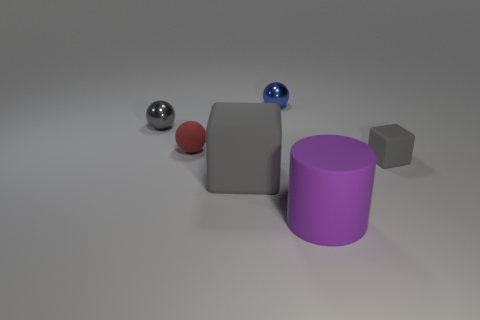Subtract all small rubber balls. How many balls are left? 2 Subtract 1 balls. How many balls are left? 2 Add 3 small red rubber things. How many objects exist? 9 Subtract all cylinders. How many objects are left? 5 Subtract all rubber balls. Subtract all cylinders. How many objects are left? 4 Add 4 tiny metallic balls. How many tiny metallic balls are left? 6 Add 6 green metallic spheres. How many green metallic spheres exist? 6 Subtract 0 blue cylinders. How many objects are left? 6 